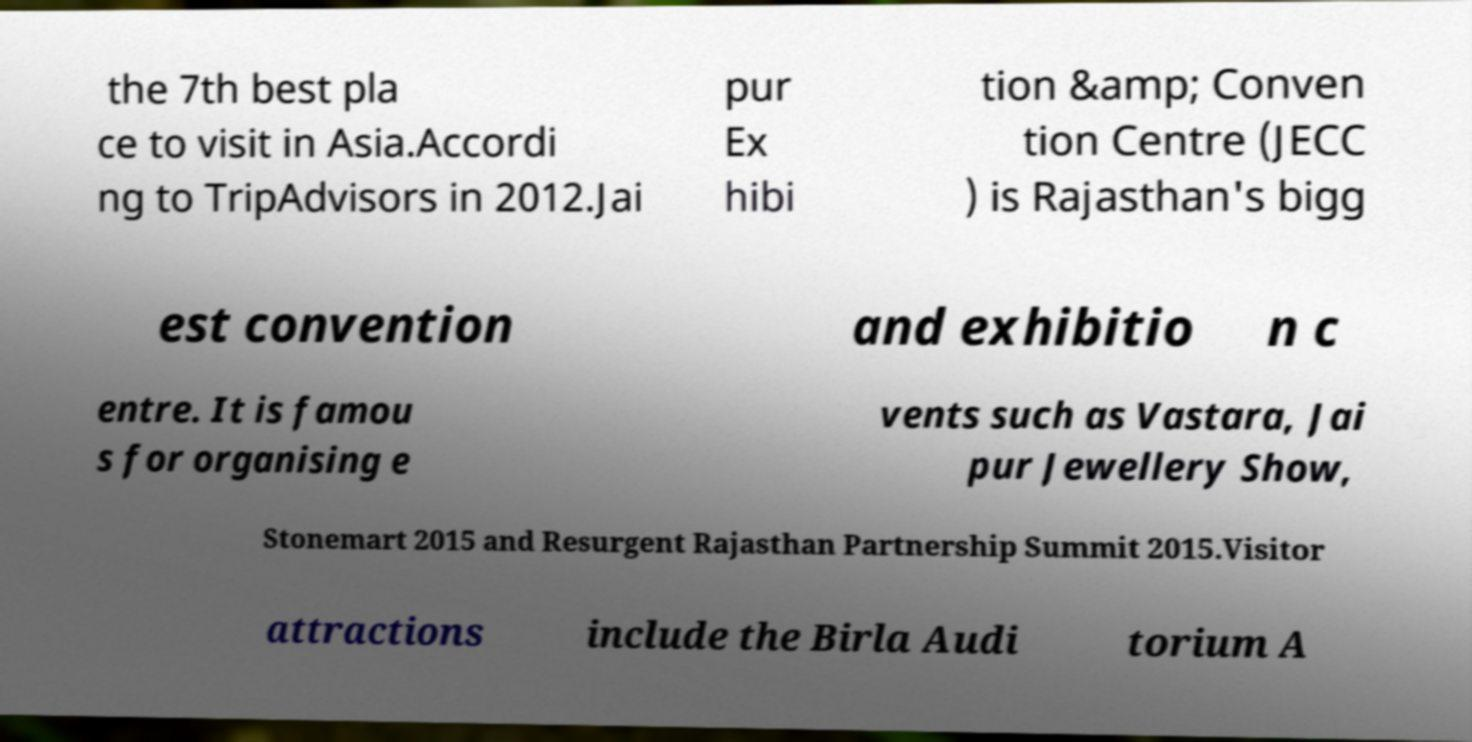I need the written content from this picture converted into text. Can you do that? the 7th best pla ce to visit in Asia.Accordi ng to TripAdvisors in 2012.Jai pur Ex hibi tion &amp; Conven tion Centre (JECC ) is Rajasthan's bigg est convention and exhibitio n c entre. It is famou s for organising e vents such as Vastara, Jai pur Jewellery Show, Stonemart 2015 and Resurgent Rajasthan Partnership Summit 2015.Visitor attractions include the Birla Audi torium A 